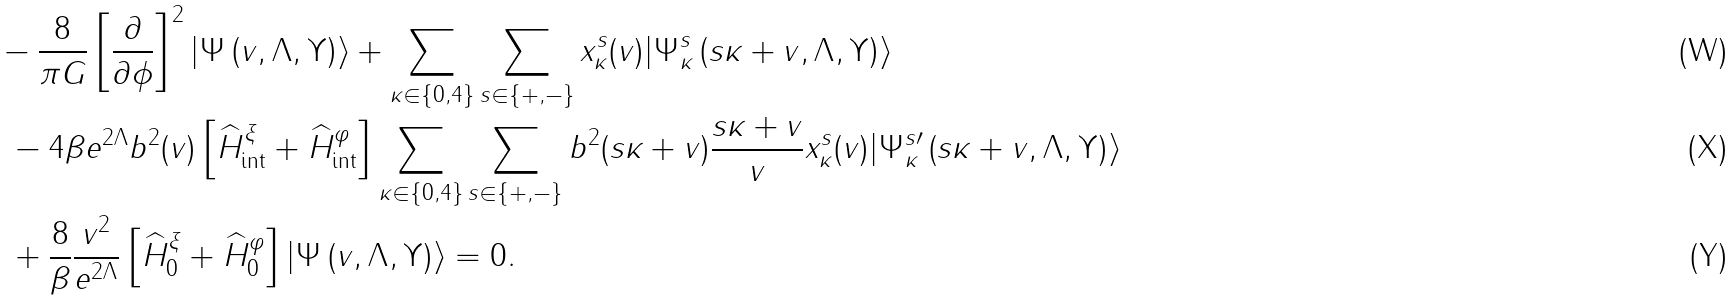<formula> <loc_0><loc_0><loc_500><loc_500>& - \frac { 8 } { \pi G } \left [ \frac { \partial } { \partial \phi } \right ] ^ { 2 } | \Psi \left ( v , \Lambda , \Upsilon \right ) \rangle + \sum _ { \kappa \in \{ 0 , 4 \} } \sum _ { s \in \{ + , - \} } x _ { \kappa } ^ { s } ( v ) | \Psi _ { \kappa } ^ { s } \left ( s \kappa + v , \Lambda , \Upsilon \right ) \rangle \\ & \ - 4 \beta e ^ { 2 \Lambda } b ^ { 2 } ( v ) \left [ \widehat { H } _ { \text {int} } ^ { \xi } + \widehat { H } _ { \text {int} } ^ { \varphi } \right ] \sum _ { \kappa \in \{ 0 , 4 \} } \sum _ { s \in \{ + , - \} } b ^ { 2 } ( s \kappa + v ) \frac { s \kappa + v } { v } x _ { \kappa } ^ { s } ( { v } ) | \Psi _ { \kappa } ^ { s \prime } \left ( s \kappa + v , \Lambda , \Upsilon \right ) \rangle \\ & \ + \frac { 8 } { \beta } \frac { { v } ^ { 2 } } { e ^ { 2 \Lambda } } \left [ \widehat { H } _ { 0 } ^ { \xi } + \widehat { H } _ { 0 } ^ { \varphi } \right ] | \Psi \left ( v , \Lambda , \Upsilon \right ) \rangle = 0 .</formula> 